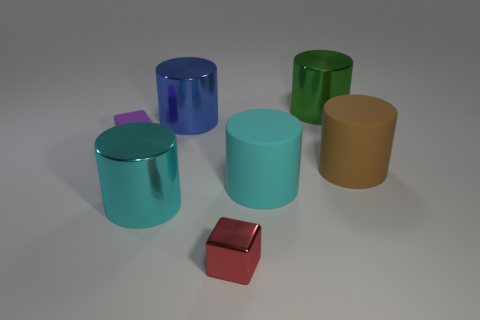What size is the rubber cylinder left of the brown cylinder?
Provide a succinct answer. Large. What number of objects are either large cyan metallic blocks or things in front of the green shiny thing?
Your answer should be very brief. 6. How many other things are the same size as the purple object?
Offer a terse response. 1. There is another thing that is the same shape as the red thing; what is it made of?
Offer a very short reply. Rubber. Are there more big brown things that are on the right side of the big green object than small brown objects?
Your answer should be compact. Yes. The large blue thing that is made of the same material as the red block is what shape?
Offer a terse response. Cylinder. Does the small cube on the right side of the small purple rubber block have the same material as the purple object?
Offer a terse response. No. There is a large shiny thing that is in front of the purple block; is its color the same as the matte thing in front of the large brown rubber cylinder?
Your answer should be compact. Yes. What number of objects are behind the red object and on the right side of the matte block?
Your response must be concise. 5. What is the large blue cylinder made of?
Provide a short and direct response. Metal. 